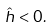<formula> <loc_0><loc_0><loc_500><loc_500>\hat { h } < 0 .</formula> 